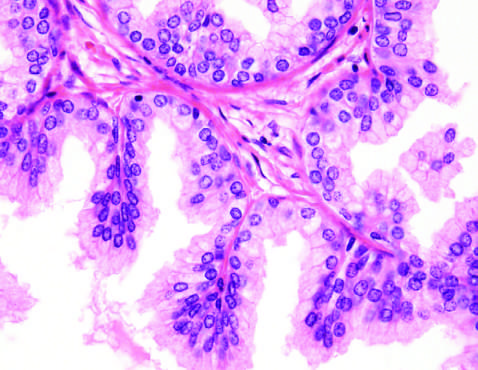what is caused predominantly by stromal, rather than glandular, proliferation in other cases of nodular hyperplasia?
Answer the question using a single word or phrase. Nodularity 